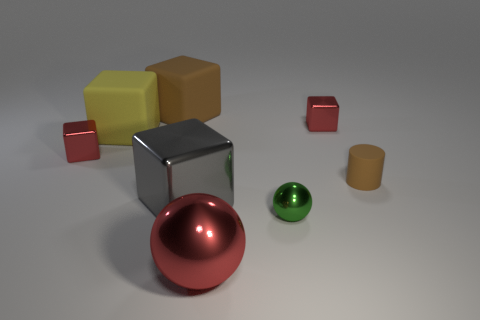Subtract all purple cylinders. How many red cubes are left? 2 Subtract all red blocks. How many blocks are left? 3 Subtract 2 blocks. How many blocks are left? 3 Subtract all large brown cubes. How many cubes are left? 4 Add 1 brown matte cylinders. How many objects exist? 9 Subtract all purple cubes. Subtract all gray balls. How many cubes are left? 5 Subtract all spheres. How many objects are left? 6 Add 3 small cubes. How many small cubes exist? 5 Subtract 1 brown blocks. How many objects are left? 7 Subtract all large red balls. Subtract all large yellow matte objects. How many objects are left? 6 